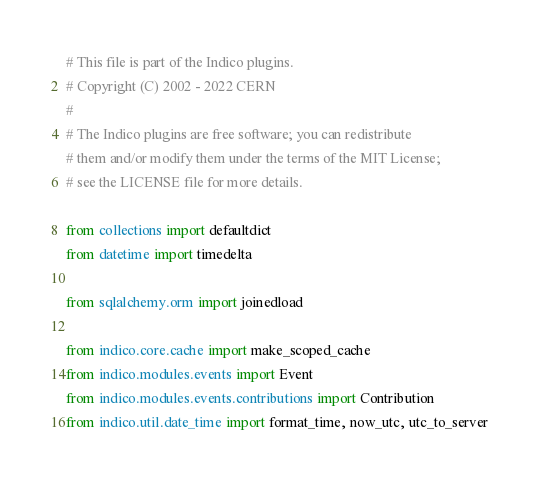Convert code to text. <code><loc_0><loc_0><loc_500><loc_500><_Python_># This file is part of the Indico plugins.
# Copyright (C) 2002 - 2022 CERN
#
# The Indico plugins are free software; you can redistribute
# them and/or modify them under the terms of the MIT License;
# see the LICENSE file for more details.

from collections import defaultdict
from datetime import timedelta

from sqlalchemy.orm import joinedload

from indico.core.cache import make_scoped_cache
from indico.modules.events import Event
from indico.modules.events.contributions import Contribution
from indico.util.date_time import format_time, now_utc, utc_to_server
</code> 